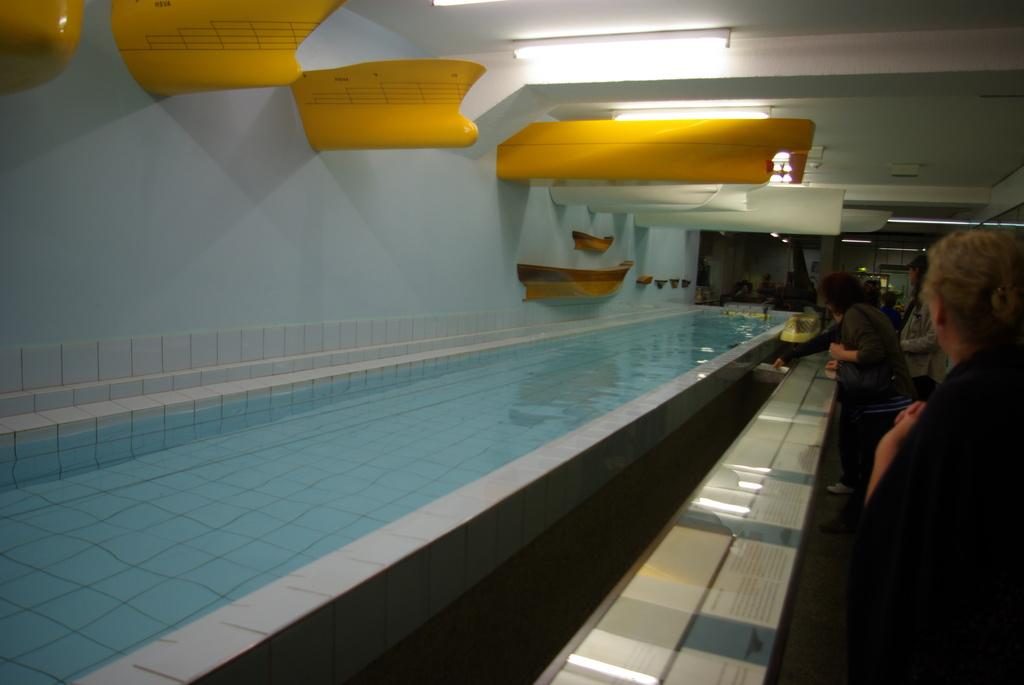What is visible in the image? Water is visible in the image, along with people standing and lights in the background. What color is the roof in the image? The roof is white in color. What objects in the image have a yellow color? There are yellow objects in the objects in the image. What rhythm is the father playing on the faucet in the image? There is no father or faucet present in the image, so it is not possible to answer that question. 